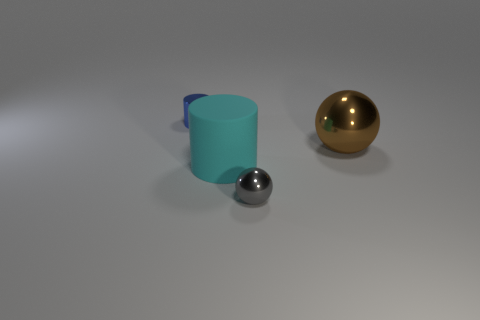Is the number of large red rubber things less than the number of gray spheres?
Provide a succinct answer. Yes. Is the material of the tiny sphere the same as the blue object?
Offer a very short reply. Yes. How many other objects are the same size as the blue cylinder?
Keep it short and to the point. 1. There is a metal ball behind the small metallic object in front of the big cyan matte thing; what is its color?
Your answer should be very brief. Brown. What number of other objects are there of the same shape as the small blue object?
Offer a very short reply. 1. Are there any other tiny blue things made of the same material as the blue thing?
Your answer should be compact. No. There is a thing that is the same size as the rubber cylinder; what material is it?
Give a very brief answer. Metal. What is the color of the tiny object in front of the tiny object that is behind the big brown shiny ball that is behind the cyan thing?
Ensure brevity in your answer.  Gray. There is a metal object in front of the brown shiny sphere; is it the same shape as the shiny object that is to the left of the small ball?
Your answer should be very brief. No. What number of big yellow shiny balls are there?
Provide a short and direct response. 0. 